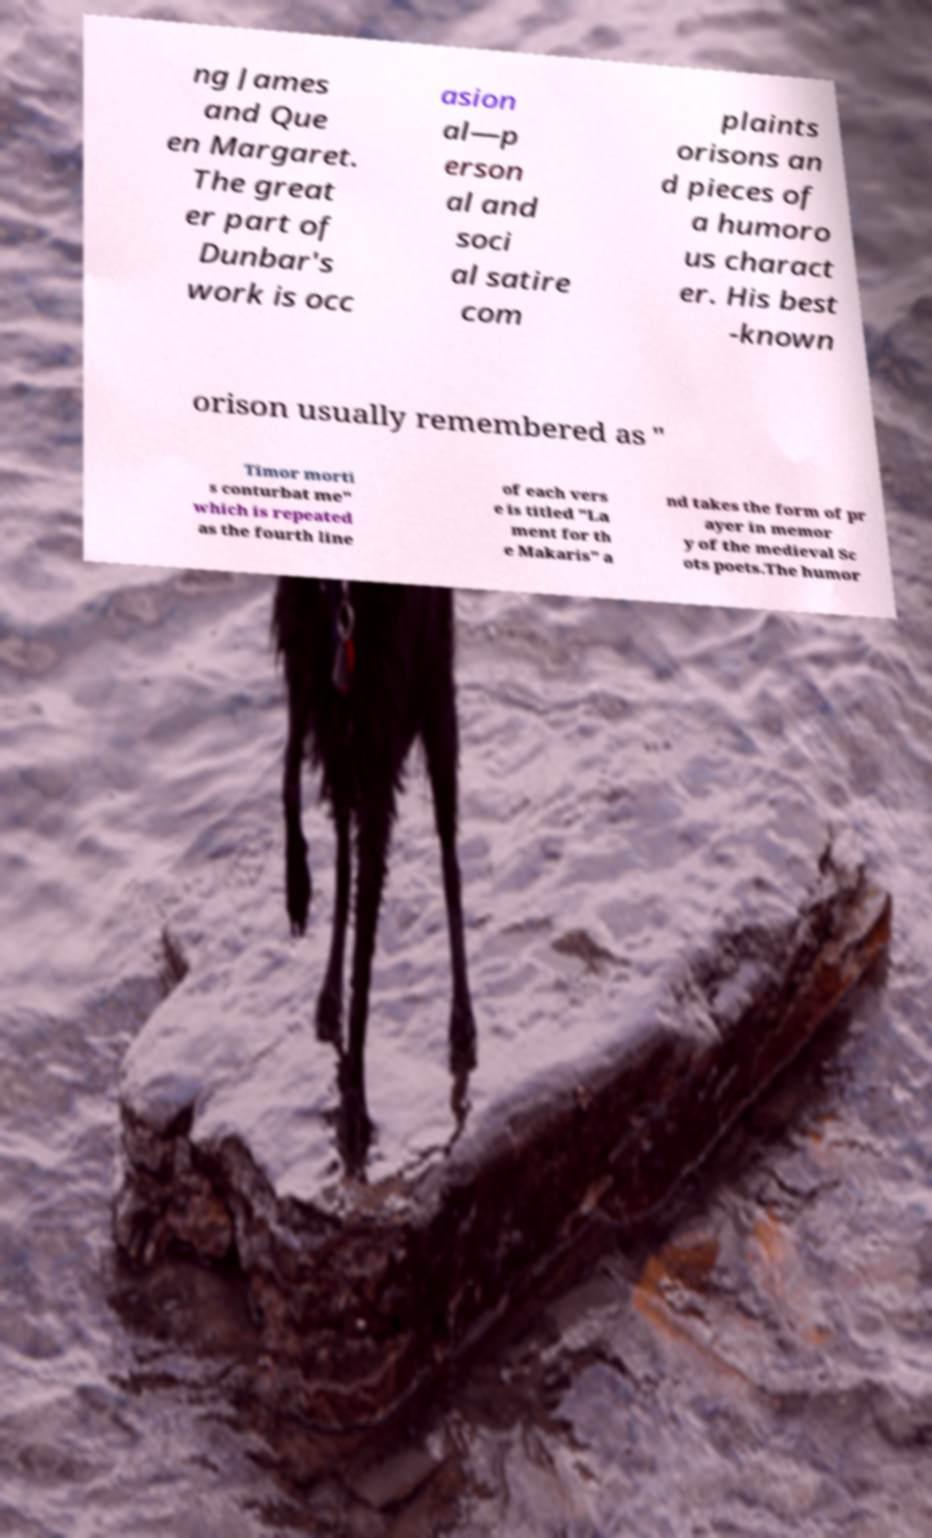Could you extract and type out the text from this image? ng James and Que en Margaret. The great er part of Dunbar's work is occ asion al—p erson al and soci al satire com plaints orisons an d pieces of a humoro us charact er. His best -known orison usually remembered as " Timor morti s conturbat me" which is repeated as the fourth line of each vers e is titled "La ment for th e Makaris" a nd takes the form of pr ayer in memor y of the medieval Sc ots poets.The humor 